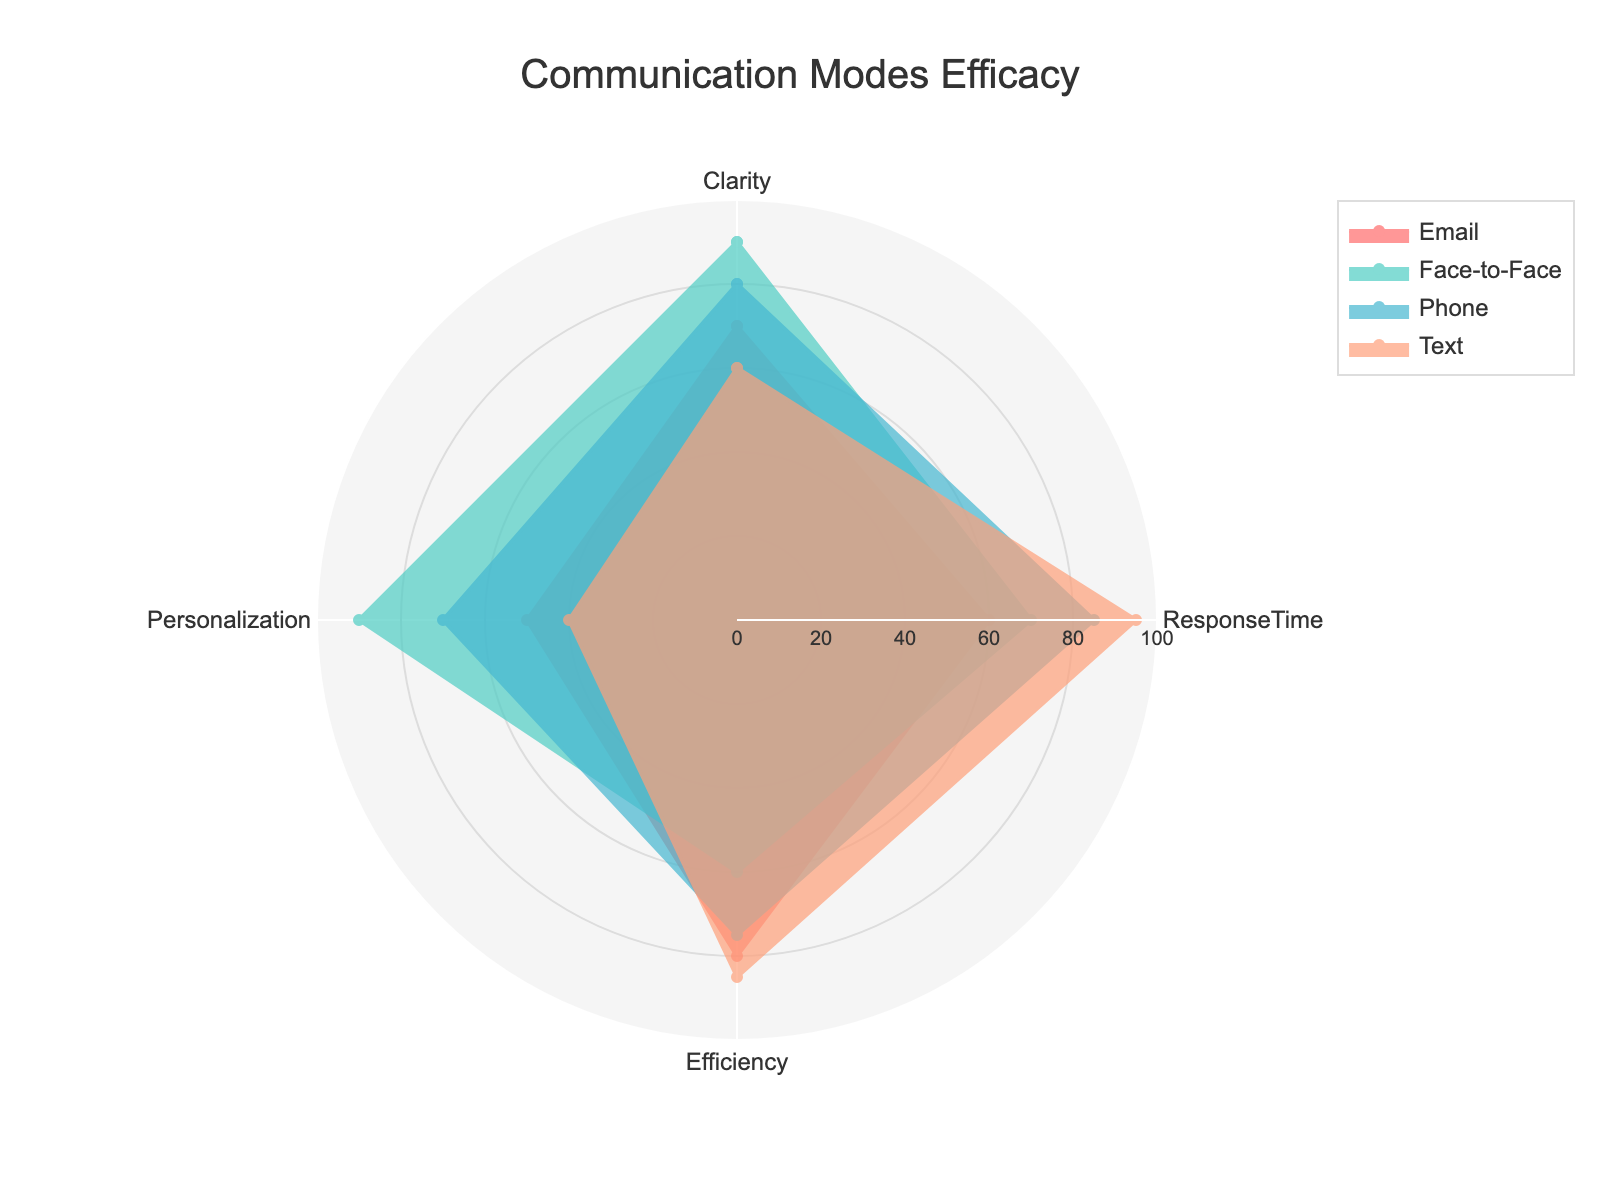What is the title of the radar chart? The title is presented at the top center of the chart within the defined layout settings. It is meant to provide a clear understanding of what the chart represents.
Answer: Communication Modes Efficacy How many communication modes are compared in the radar chart? The radar chart includes a separate trace for each mode, clearly labeled in the legend and the data columns provided.
Answer: 4 Which communication mode has the highest clarity rating? By observing the radial distance on the 'Clarity' axis, you can determine the mode with the longest distance in that dimension.
Answer: Face-to-Face What is the average response time across all communication modes? Sum each mode's response time value, then divide by the number of communication modes (60 + 70 + 85 + 95) / 4 = 310 / 4 = 77.5
Answer: 77.5 For personalization, which two communication modes show the greatest difference, and what is that difference? Identify the highest and lowest values in 'Personalization', then subtract the lowest from the highest (90 - 40 = 50).
Answer: Face-to-Face and Text, 50 Which communication mode's efficiency is closest to 70? Check the values for 'Efficiency' provided in the dataset and find the mode with a value nearest to 70.
Answer: Phone Between Email and Text modes, which one has higher overall ratings if you sum up all the categories for each mode? Sum values for each metric for Email and Text and compare. Email: (70 + 60 + 80 + 50) = 260, Text: (60 + 95 + 85 + 40) = 280
Answer: Text Arrange the communication modes in descending order based on their response time efficiency. Observe each mode's response time value and sort in descending order.
Answer: Text, Phone, Face-to-Face, Email Is there any mode where the clarity rating and the efficiency rating are equal? Compare 'Clarity' and 'Efficiency' values for each mode to see if any are the same.
Answer: No Which communication mode shows the least variability across all four categories? Calculate the range (max - min) for each mode and identify the mode with the smallest range.
Answer: Face-to-Face 